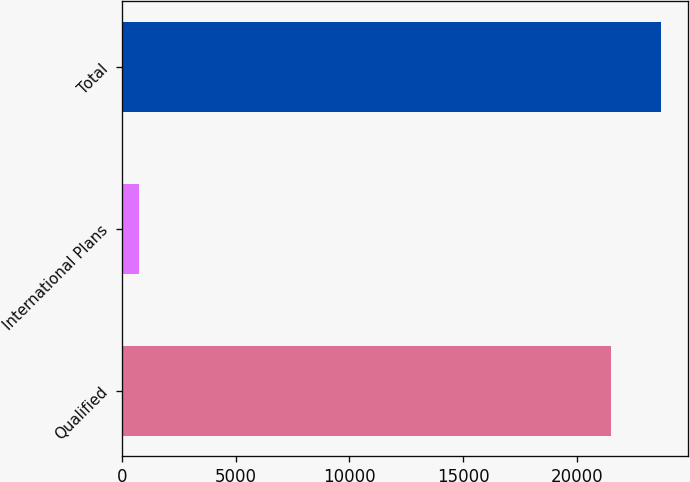<chart> <loc_0><loc_0><loc_500><loc_500><bar_chart><fcel>Qualified<fcel>International Plans<fcel>Total<nl><fcel>21532<fcel>746<fcel>23717.4<nl></chart> 